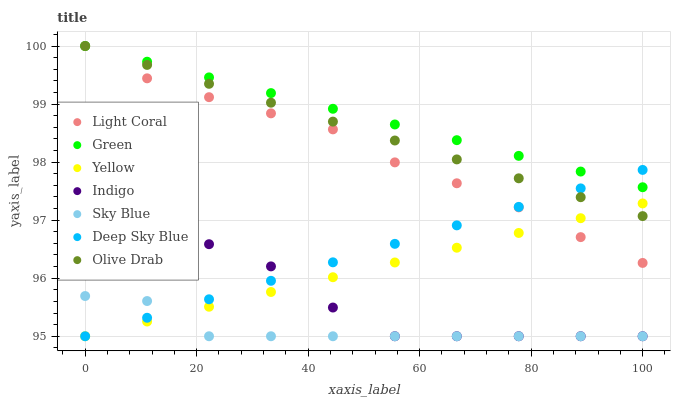Does Sky Blue have the minimum area under the curve?
Answer yes or no. Yes. Does Green have the maximum area under the curve?
Answer yes or no. Yes. Does Yellow have the minimum area under the curve?
Answer yes or no. No. Does Yellow have the maximum area under the curve?
Answer yes or no. No. Is Green the smoothest?
Answer yes or no. Yes. Is Indigo the roughest?
Answer yes or no. Yes. Is Yellow the smoothest?
Answer yes or no. No. Is Yellow the roughest?
Answer yes or no. No. Does Indigo have the lowest value?
Answer yes or no. Yes. Does Light Coral have the lowest value?
Answer yes or no. No. Does Olive Drab have the highest value?
Answer yes or no. Yes. Does Yellow have the highest value?
Answer yes or no. No. Is Sky Blue less than Green?
Answer yes or no. Yes. Is Green greater than Yellow?
Answer yes or no. Yes. Does Deep Sky Blue intersect Yellow?
Answer yes or no. Yes. Is Deep Sky Blue less than Yellow?
Answer yes or no. No. Is Deep Sky Blue greater than Yellow?
Answer yes or no. No. Does Sky Blue intersect Green?
Answer yes or no. No. 